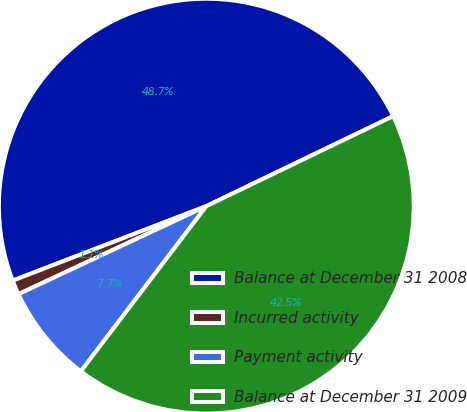Convert chart to OTSL. <chart><loc_0><loc_0><loc_500><loc_500><pie_chart><fcel>Balance at December 31 2008<fcel>Incurred activity<fcel>Payment activity<fcel>Balance at December 31 2009<nl><fcel>48.7%<fcel>1.13%<fcel>7.69%<fcel>42.48%<nl></chart> 